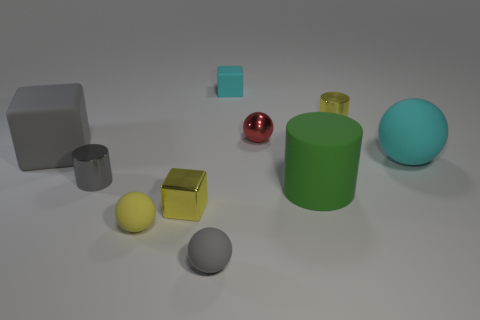Does the green matte cylinder have the same size as the gray matte block? yes 